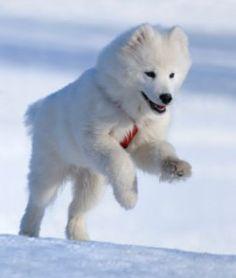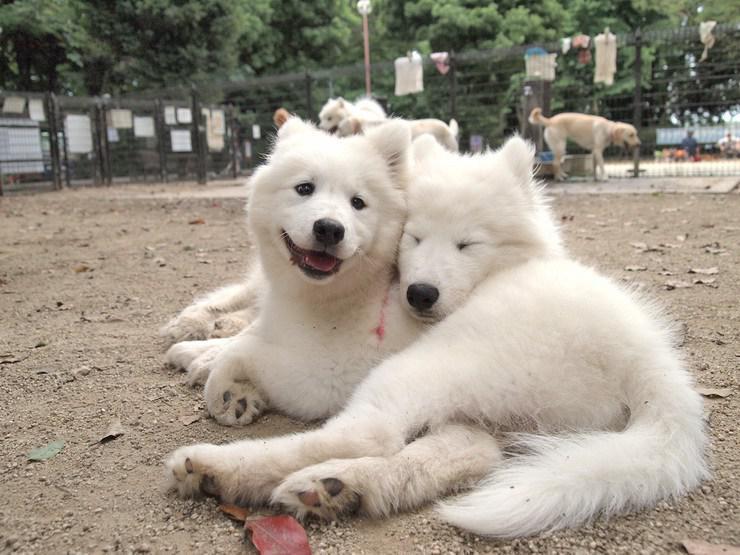The first image is the image on the left, the second image is the image on the right. Considering the images on both sides, is "An image shows a white dog posed indoors in a white room." valid? Answer yes or no. No. The first image is the image on the left, the second image is the image on the right. For the images displayed, is the sentence "At least one of the dogs is standing outside." factually correct? Answer yes or no. Yes. 